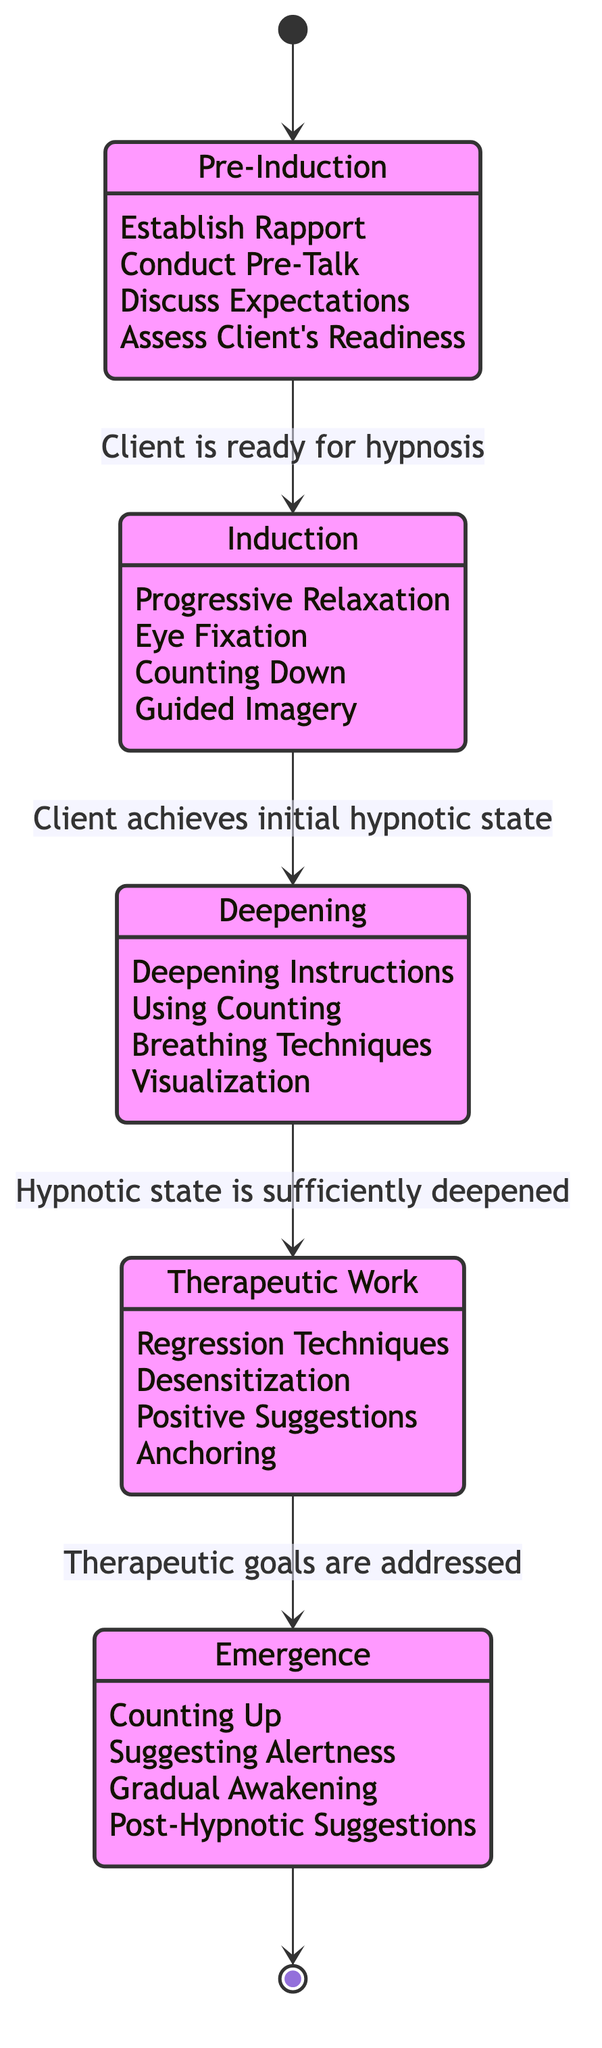What is the first state in the diagram? The diagram starts at the initial state before any transitions, which is labeled "Pre-Induction."
Answer: Pre-Induction How many states are shown in the diagram? By counting the distinct states in the diagram, we see there are five: Pre-Induction, Induction, Deepening, Therapeutic Work, and Emergence.
Answer: 5 What event triggers the transition from Induction to Deepening? The transition from Induction to Deepening occurs when the event "Client achieves initial hypnotic state" takes place.
Answer: Client achieves initial hypnotic state What activities are conducted during the Pre-Induction phase? The activities listed under Pre-Induction are Establish Rapport, Conduct Pre-Talk, Discuss Expectations, and Assess Client's Readiness.
Answer: Establish Rapport, Conduct Pre-Talk, Discuss Expectations, Assess Client's Readiness In which state is Therapeutic Work performed? Therapeutic Work is performed in the state specifically labeled "Therapeutic Work."
Answer: Therapeutic Work What is the final state reached after Emergence? The final state after Emergence returns to the initial state, which is represented as "[*]" in the diagram.
Answer: [*] How does one transition from Deepening to Therapeutic Work? The transition from Deepening to Therapeutic Work is made when the event "Hypnotic state is sufficiently deepened" occurs.
Answer: Hypnotic state is sufficiently deepened Which state includes the technique of Guided Imagery? Guided Imagery is one of the activities performed during the Induction phase.
Answer: Induction What happens at the beginning of the diagram? At the beginning of the diagram, the state is initialized, indicated by the transition from "[*]" to "Pre-Induction."
Answer: Pre-Induction 